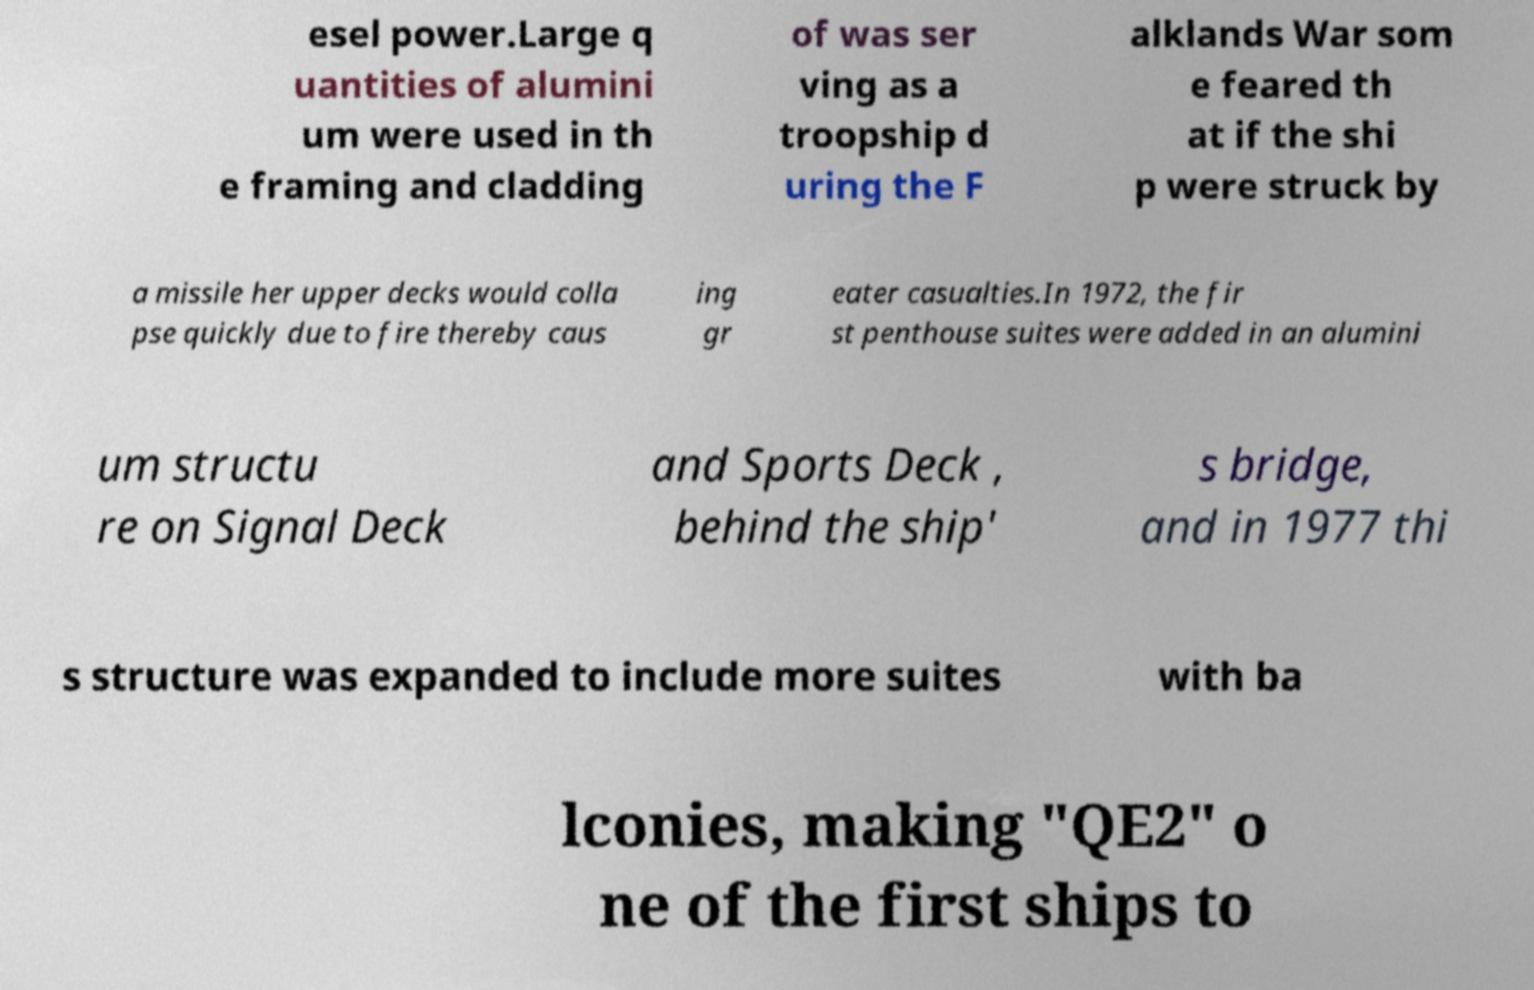Can you read and provide the text displayed in the image?This photo seems to have some interesting text. Can you extract and type it out for me? esel power.Large q uantities of alumini um were used in th e framing and cladding of was ser ving as a troopship d uring the F alklands War som e feared th at if the shi p were struck by a missile her upper decks would colla pse quickly due to fire thereby caus ing gr eater casualties.In 1972, the fir st penthouse suites were added in an alumini um structu re on Signal Deck and Sports Deck , behind the ship' s bridge, and in 1977 thi s structure was expanded to include more suites with ba lconies, making "QE2" o ne of the first ships to 